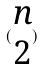Convert formula to latex. <formula><loc_0><loc_0><loc_500><loc_500>( \begin{matrix} n \\ 2 \end{matrix} )</formula> 